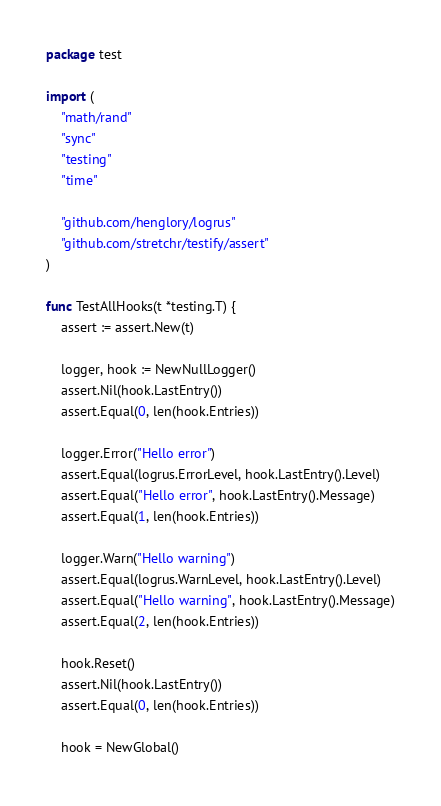<code> <loc_0><loc_0><loc_500><loc_500><_Go_>package test

import (
	"math/rand"
	"sync"
	"testing"
	"time"

	"github.com/henglory/logrus"
	"github.com/stretchr/testify/assert"
)

func TestAllHooks(t *testing.T) {
	assert := assert.New(t)

	logger, hook := NewNullLogger()
	assert.Nil(hook.LastEntry())
	assert.Equal(0, len(hook.Entries))

	logger.Error("Hello error")
	assert.Equal(logrus.ErrorLevel, hook.LastEntry().Level)
	assert.Equal("Hello error", hook.LastEntry().Message)
	assert.Equal(1, len(hook.Entries))

	logger.Warn("Hello warning")
	assert.Equal(logrus.WarnLevel, hook.LastEntry().Level)
	assert.Equal("Hello warning", hook.LastEntry().Message)
	assert.Equal(2, len(hook.Entries))

	hook.Reset()
	assert.Nil(hook.LastEntry())
	assert.Equal(0, len(hook.Entries))

	hook = NewGlobal()
</code> 